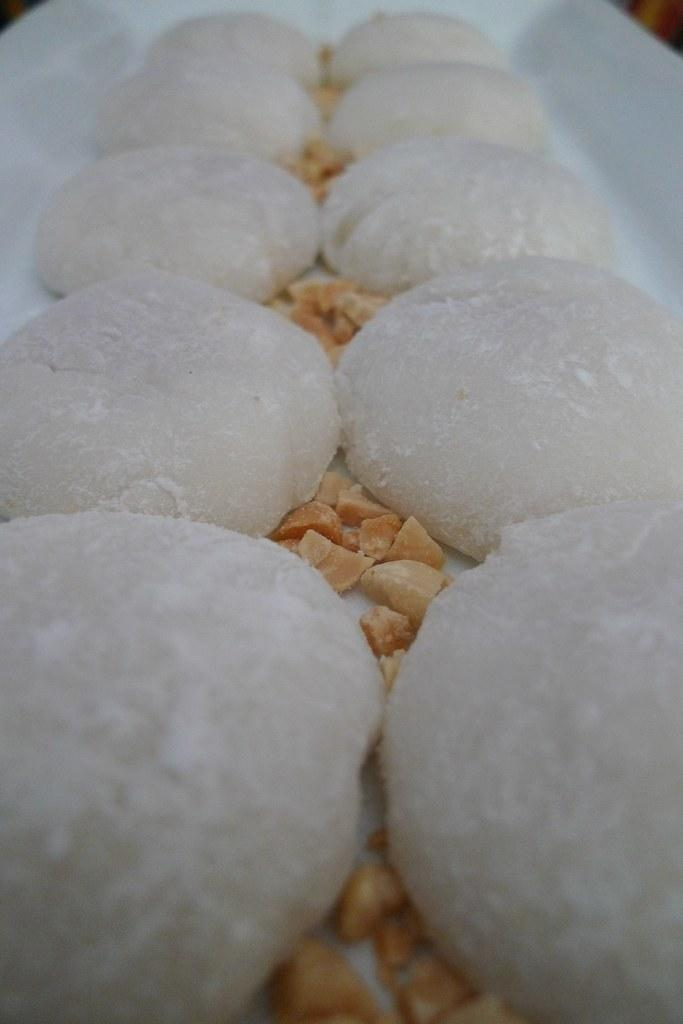What is present on the plate in the image? There are food items on the plate in the image. Can you hear the voice of the house in the image? There is no house or voice present in the image; it only features a plate with food items. 